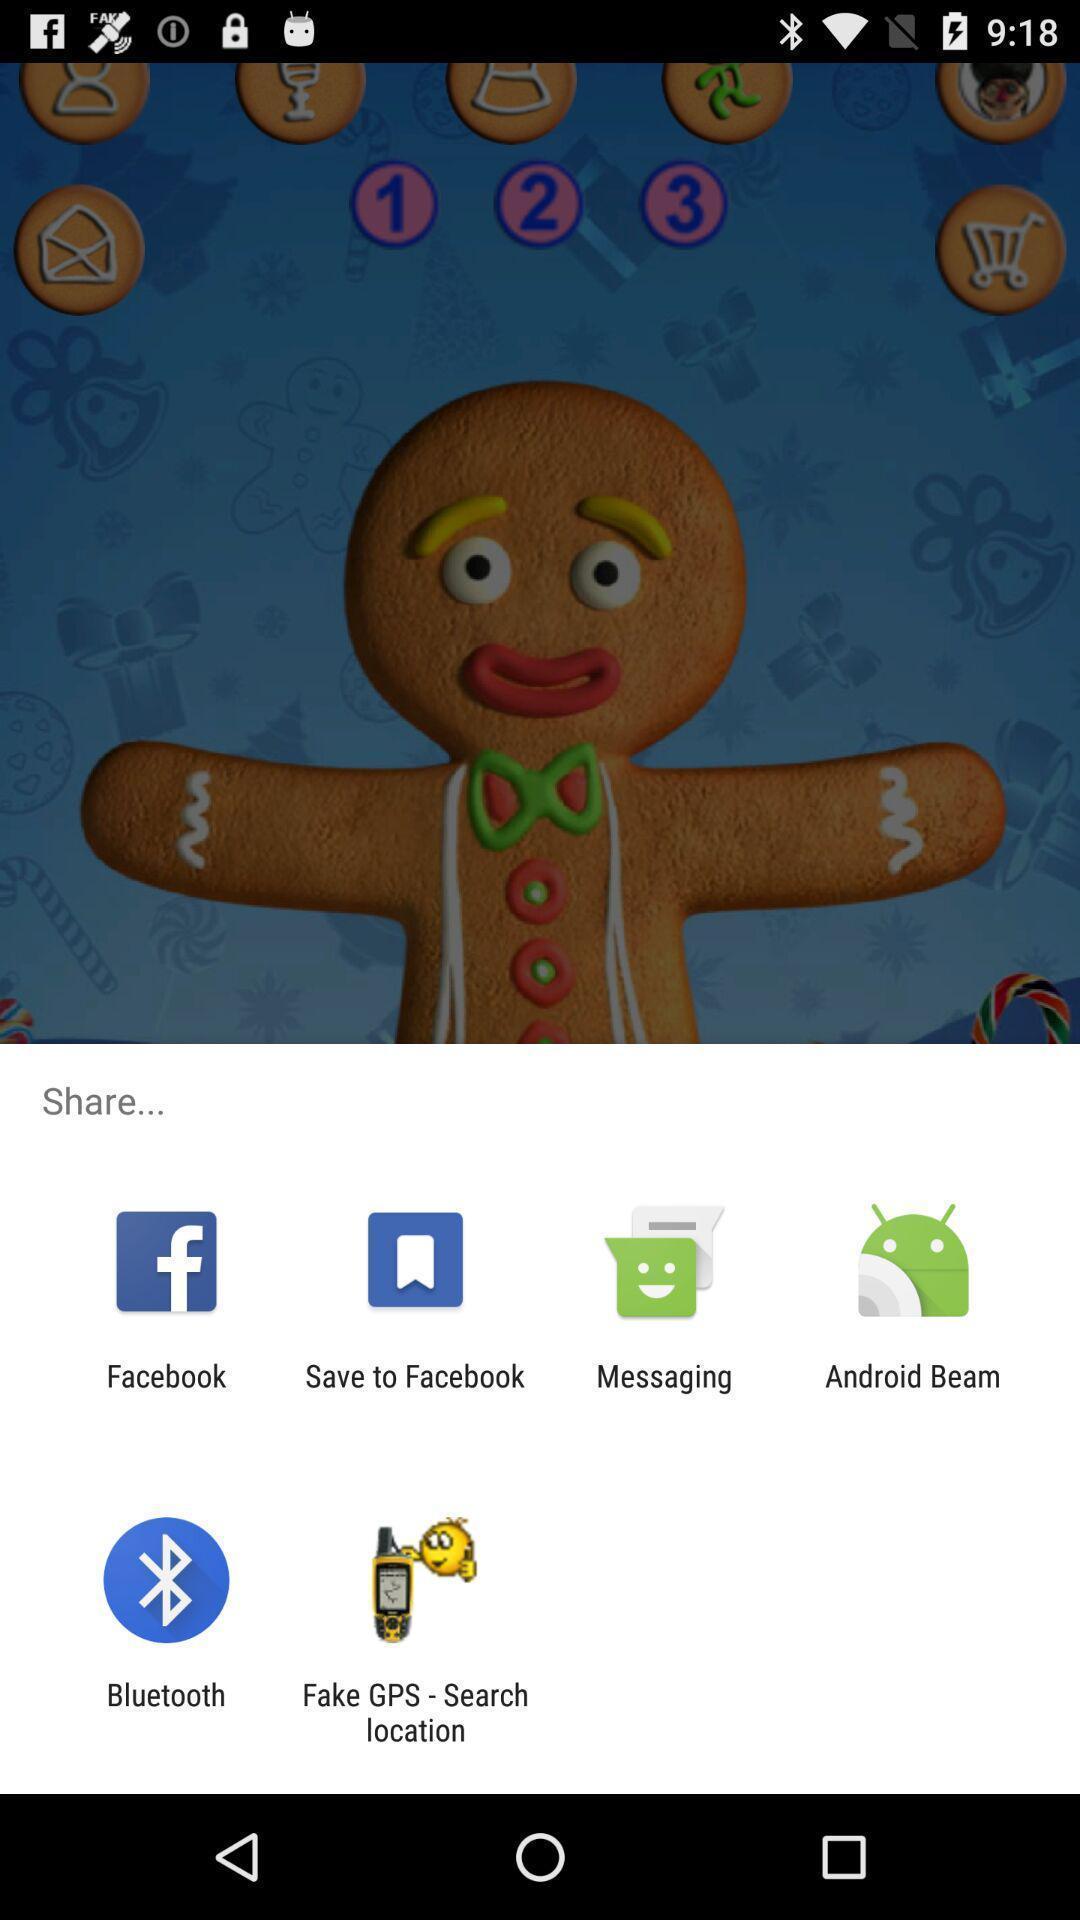Describe the key features of this screenshot. Screen showing various applications to share. 